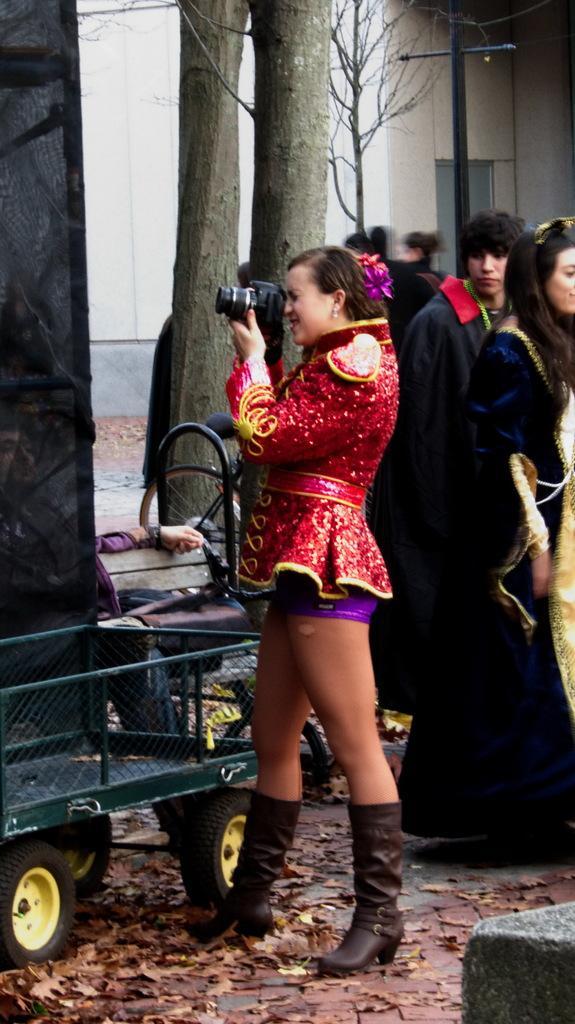Can you describe this image briefly? In this image i can see a woman holding a camera and wearing a red color skirt , standing in front of the cart vehicle , on the right side I can see there are few persons standing on the floor, in the background I can see trees and the buildings and poles visible. 